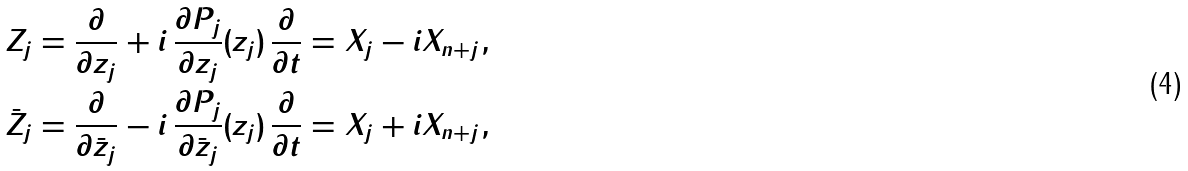Convert formula to latex. <formula><loc_0><loc_0><loc_500><loc_500>Z _ { j } & = \frac { \partial } { \partial z _ { j } } + i \, \frac { \partial P _ { j } } { \partial z _ { j } } ( z _ { j } ) \, \frac { \partial } { \partial t } = X _ { j } - i X _ { n + j } , \\ \bar { Z } _ { j } & = \frac { \partial } { \partial \bar { z } _ { j } } - i \, \frac { \partial P _ { j } } { \partial \bar { z } _ { j } } ( z _ { j } ) \, \frac { \partial } { \partial t } = X _ { j } + i X _ { n + j } ,</formula> 